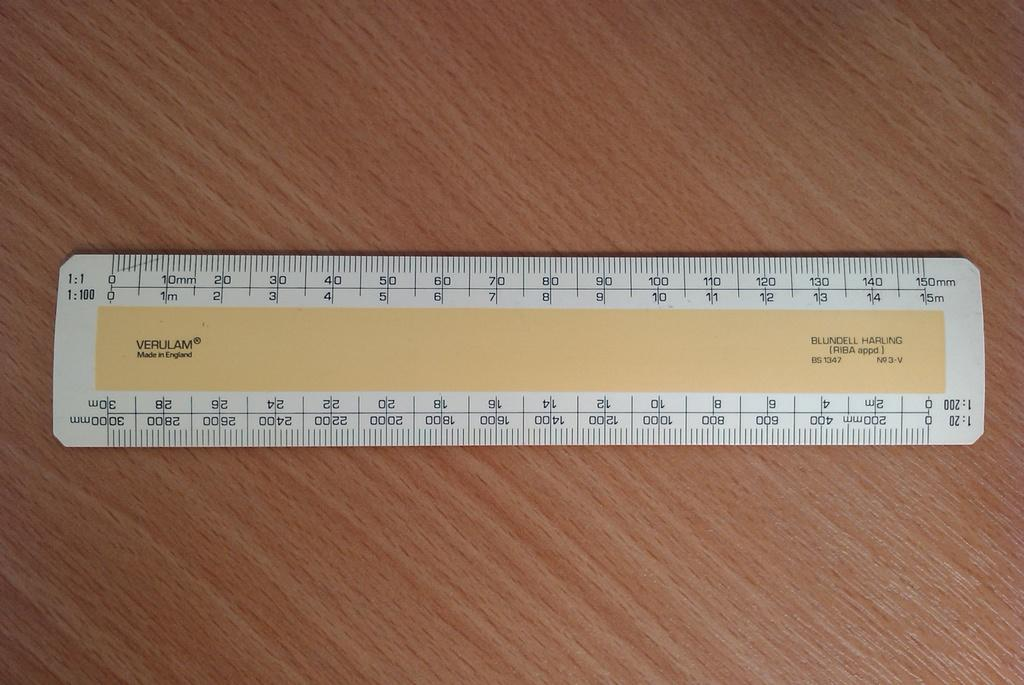Provide a one-sentence caption for the provided image. A yellow and white Verulam ruler made in England. 